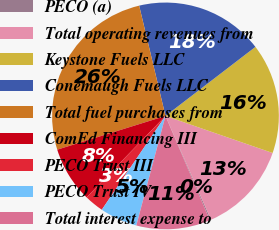Convert chart. <chart><loc_0><loc_0><loc_500><loc_500><pie_chart><fcel>PECO (a)<fcel>Total operating revenues from<fcel>Keystone Fuels LLC<fcel>Conemaugh Fuels LLC<fcel>Total fuel purchases from<fcel>ComEd Financing III<fcel>PECO Trust III<fcel>PECO Trust IV<fcel>Total interest expense to<nl><fcel>0.17%<fcel>13.13%<fcel>15.72%<fcel>18.31%<fcel>26.08%<fcel>7.94%<fcel>2.76%<fcel>5.35%<fcel>10.54%<nl></chart> 